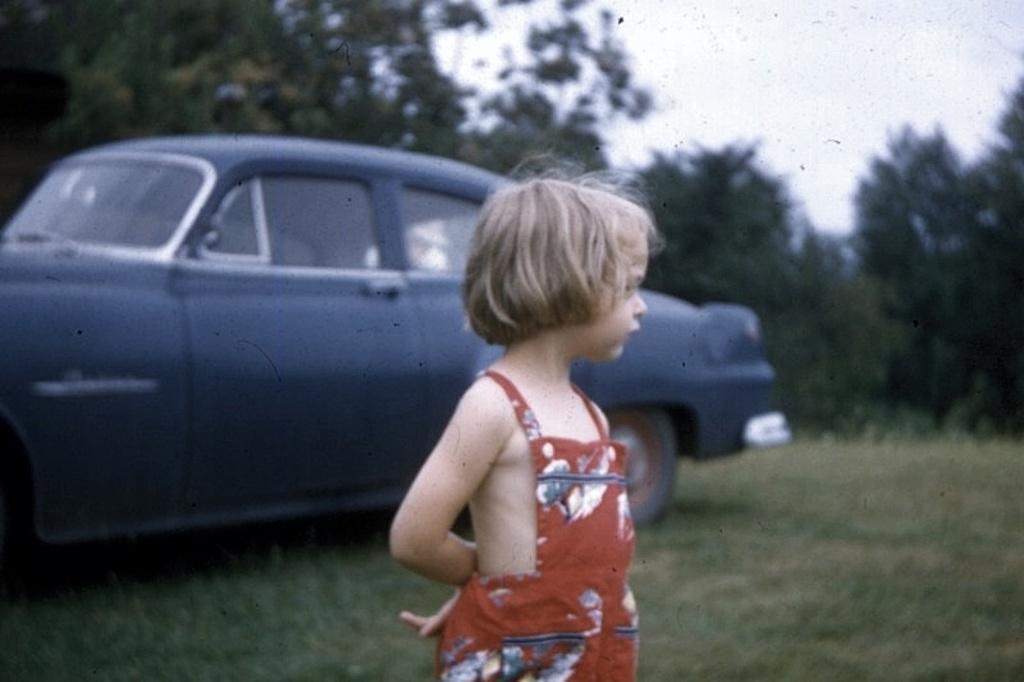How would you summarize this image in a sentence or two? In the picture I can see a kid wearing red dress is standing on a greenery ground and there is a car behind her and there are trees in the background. 